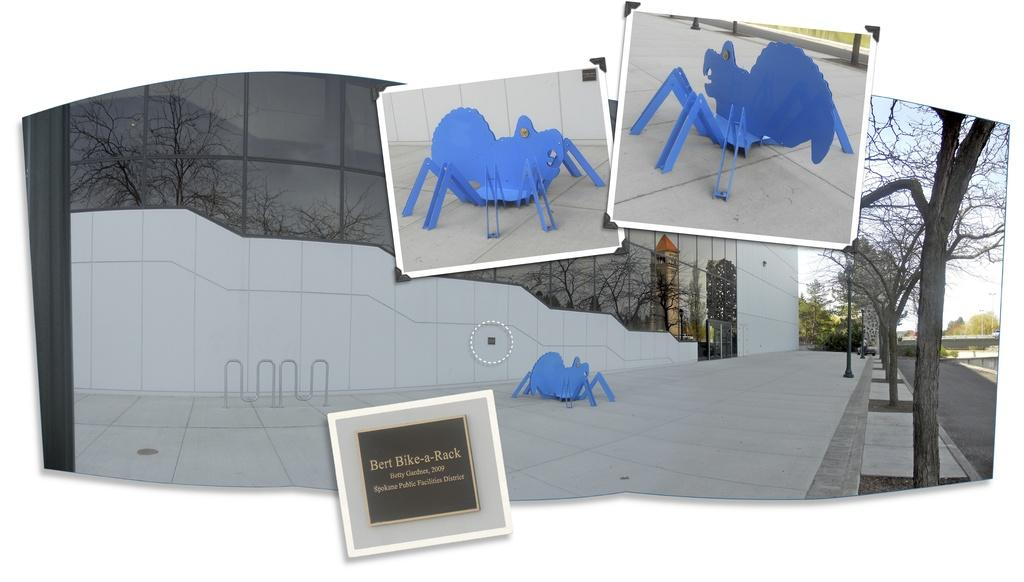<image>
Offer a succinct explanation of the picture presented. An artistic display at Bert Bike-a-Rack made in 2009. 